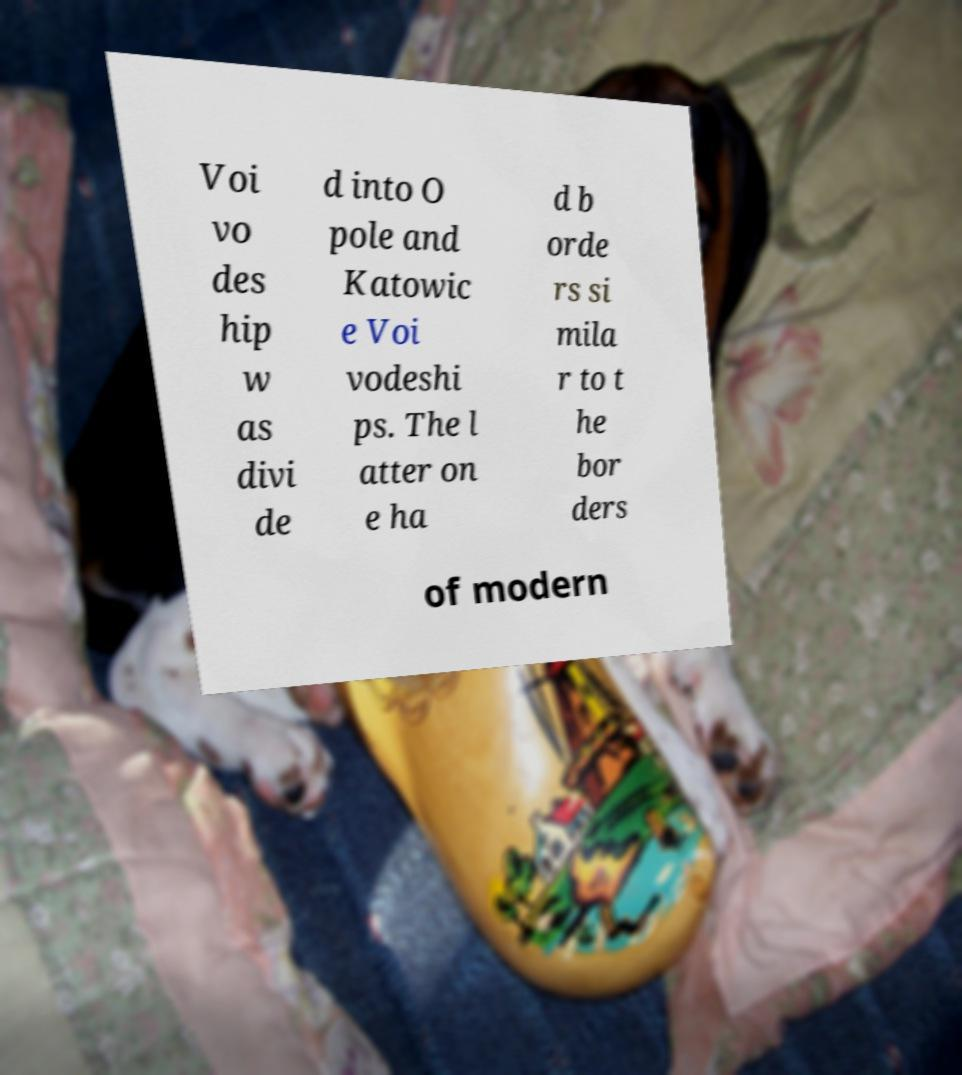What messages or text are displayed in this image? I need them in a readable, typed format. Voi vo des hip w as divi de d into O pole and Katowic e Voi vodeshi ps. The l atter on e ha d b orde rs si mila r to t he bor ders of modern 